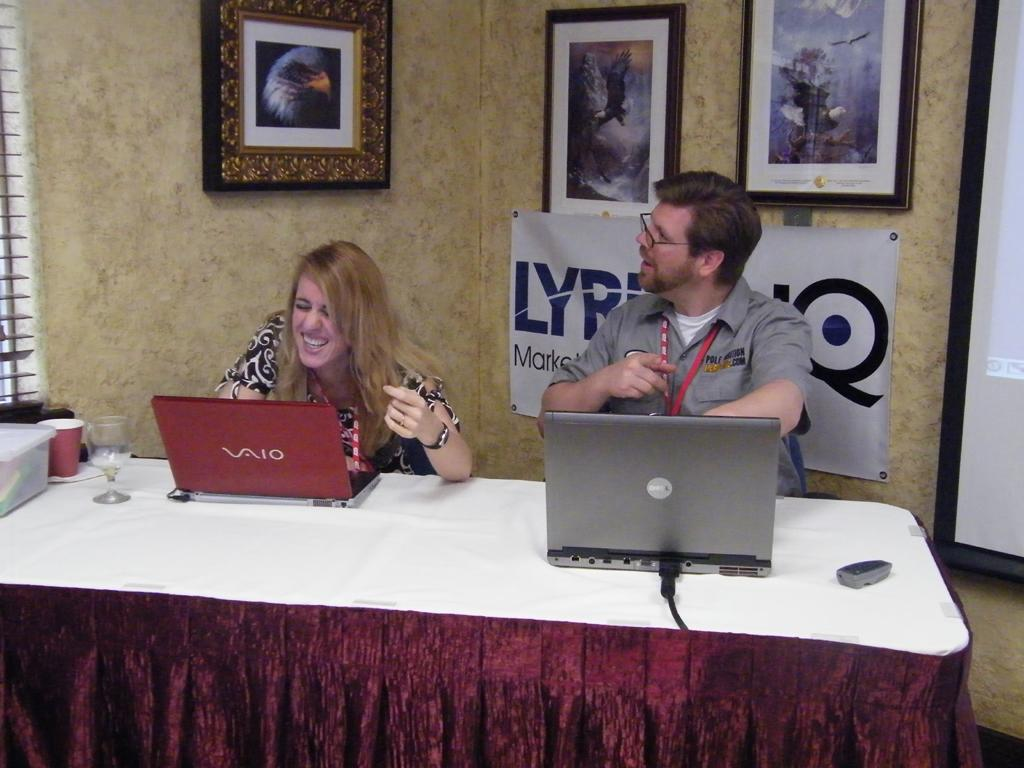What piece of furniture is present in the image? There is a table in the image. What electronic devices are on the table? There are two laptops on the table. Who is using the laptops? There are two people operating the laptops. What additional item can be seen in the image? There is a banner visible in the image. What decorative items are on the wall? There are three photo frames on the wall. What type of sofa is present in the image? There is no sofa present in the image. How many bites can be seen on the laptops in the image? The image does not show any bites on the laptops; they are not edible items. 